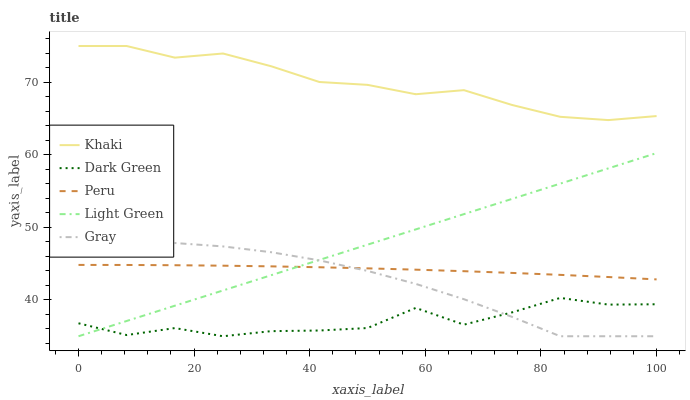Does Light Green have the minimum area under the curve?
Answer yes or no. No. Does Light Green have the maximum area under the curve?
Answer yes or no. No. Is Khaki the smoothest?
Answer yes or no. No. Is Khaki the roughest?
Answer yes or no. No. Does Khaki have the lowest value?
Answer yes or no. No. Does Light Green have the highest value?
Answer yes or no. No. Is Dark Green less than Peru?
Answer yes or no. Yes. Is Peru greater than Dark Green?
Answer yes or no. Yes. Does Dark Green intersect Peru?
Answer yes or no. No. 